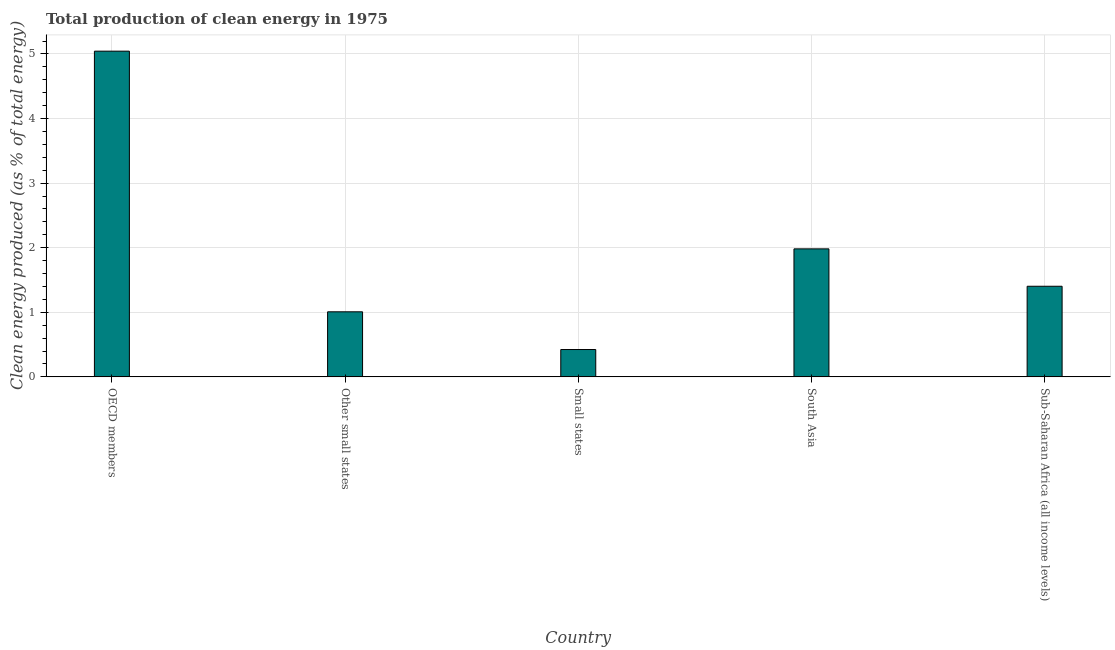What is the title of the graph?
Provide a succinct answer. Total production of clean energy in 1975. What is the label or title of the X-axis?
Ensure brevity in your answer.  Country. What is the label or title of the Y-axis?
Your answer should be very brief. Clean energy produced (as % of total energy). What is the production of clean energy in Small states?
Your response must be concise. 0.42. Across all countries, what is the maximum production of clean energy?
Offer a very short reply. 5.04. Across all countries, what is the minimum production of clean energy?
Your answer should be compact. 0.42. In which country was the production of clean energy maximum?
Offer a very short reply. OECD members. In which country was the production of clean energy minimum?
Provide a succinct answer. Small states. What is the sum of the production of clean energy?
Your answer should be very brief. 9.86. What is the difference between the production of clean energy in Small states and Sub-Saharan Africa (all income levels)?
Offer a very short reply. -0.98. What is the average production of clean energy per country?
Provide a short and direct response. 1.97. What is the median production of clean energy?
Offer a terse response. 1.4. In how many countries, is the production of clean energy greater than 4 %?
Make the answer very short. 1. What is the ratio of the production of clean energy in Small states to that in Sub-Saharan Africa (all income levels)?
Make the answer very short. 0.3. Is the production of clean energy in Other small states less than that in Sub-Saharan Africa (all income levels)?
Keep it short and to the point. Yes. Is the difference between the production of clean energy in OECD members and Small states greater than the difference between any two countries?
Your answer should be very brief. Yes. What is the difference between the highest and the second highest production of clean energy?
Make the answer very short. 3.06. Is the sum of the production of clean energy in South Asia and Sub-Saharan Africa (all income levels) greater than the maximum production of clean energy across all countries?
Your answer should be very brief. No. What is the difference between the highest and the lowest production of clean energy?
Your answer should be compact. 4.62. How many bars are there?
Make the answer very short. 5. Are all the bars in the graph horizontal?
Keep it short and to the point. No. How many countries are there in the graph?
Give a very brief answer. 5. What is the difference between two consecutive major ticks on the Y-axis?
Ensure brevity in your answer.  1. What is the Clean energy produced (as % of total energy) in OECD members?
Keep it short and to the point. 5.04. What is the Clean energy produced (as % of total energy) in Other small states?
Your answer should be very brief. 1.01. What is the Clean energy produced (as % of total energy) in Small states?
Offer a terse response. 0.42. What is the Clean energy produced (as % of total energy) in South Asia?
Provide a short and direct response. 1.98. What is the Clean energy produced (as % of total energy) in Sub-Saharan Africa (all income levels)?
Keep it short and to the point. 1.4. What is the difference between the Clean energy produced (as % of total energy) in OECD members and Other small states?
Your answer should be compact. 4.04. What is the difference between the Clean energy produced (as % of total energy) in OECD members and Small states?
Provide a succinct answer. 4.62. What is the difference between the Clean energy produced (as % of total energy) in OECD members and South Asia?
Offer a terse response. 3.06. What is the difference between the Clean energy produced (as % of total energy) in OECD members and Sub-Saharan Africa (all income levels)?
Provide a succinct answer. 3.64. What is the difference between the Clean energy produced (as % of total energy) in Other small states and Small states?
Provide a succinct answer. 0.58. What is the difference between the Clean energy produced (as % of total energy) in Other small states and South Asia?
Provide a short and direct response. -0.97. What is the difference between the Clean energy produced (as % of total energy) in Other small states and Sub-Saharan Africa (all income levels)?
Ensure brevity in your answer.  -0.4. What is the difference between the Clean energy produced (as % of total energy) in Small states and South Asia?
Provide a short and direct response. -1.56. What is the difference between the Clean energy produced (as % of total energy) in Small states and Sub-Saharan Africa (all income levels)?
Provide a succinct answer. -0.98. What is the difference between the Clean energy produced (as % of total energy) in South Asia and Sub-Saharan Africa (all income levels)?
Your answer should be very brief. 0.58. What is the ratio of the Clean energy produced (as % of total energy) in OECD members to that in Other small states?
Keep it short and to the point. 5.01. What is the ratio of the Clean energy produced (as % of total energy) in OECD members to that in Small states?
Ensure brevity in your answer.  11.91. What is the ratio of the Clean energy produced (as % of total energy) in OECD members to that in South Asia?
Your answer should be very brief. 2.54. What is the ratio of the Clean energy produced (as % of total energy) in OECD members to that in Sub-Saharan Africa (all income levels)?
Your response must be concise. 3.6. What is the ratio of the Clean energy produced (as % of total energy) in Other small states to that in Small states?
Make the answer very short. 2.38. What is the ratio of the Clean energy produced (as % of total energy) in Other small states to that in South Asia?
Offer a very short reply. 0.51. What is the ratio of the Clean energy produced (as % of total energy) in Other small states to that in Sub-Saharan Africa (all income levels)?
Give a very brief answer. 0.72. What is the ratio of the Clean energy produced (as % of total energy) in Small states to that in South Asia?
Provide a short and direct response. 0.21. What is the ratio of the Clean energy produced (as % of total energy) in Small states to that in Sub-Saharan Africa (all income levels)?
Your answer should be compact. 0.3. What is the ratio of the Clean energy produced (as % of total energy) in South Asia to that in Sub-Saharan Africa (all income levels)?
Keep it short and to the point. 1.41. 